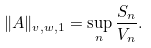<formula> <loc_0><loc_0><loc_500><loc_500>\| A \| _ { v , w , 1 } = \sup _ { n } \frac { S _ { n } } { V _ { n } } .</formula> 